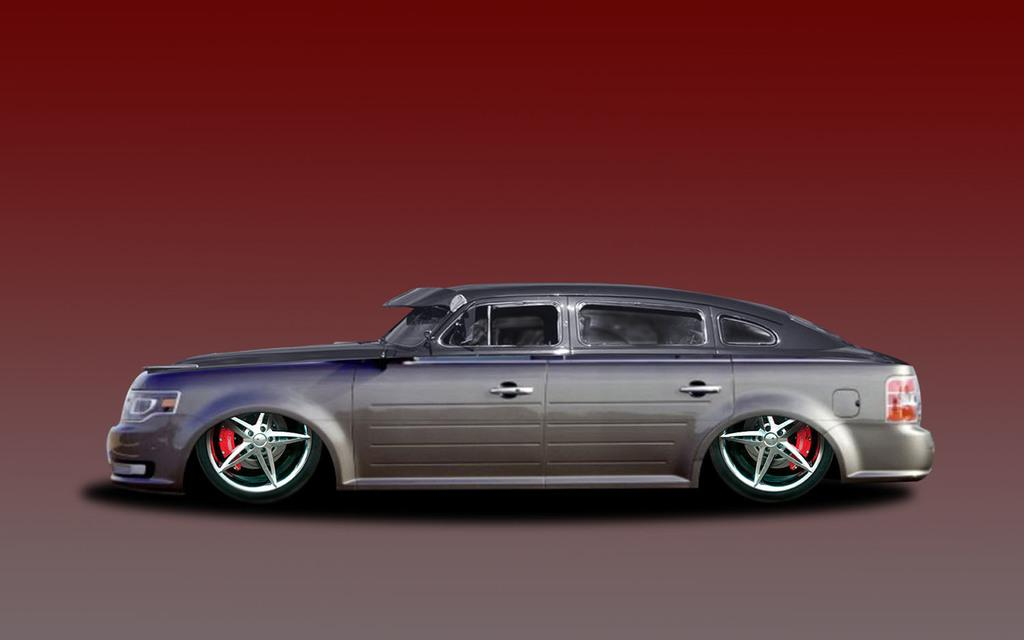What is the main subject of the image? There is a car in the image. Can you describe the background of the image? There is a brown color in the background of the image. What type of dinner is being served in the image? There is no dinner present in the image; it features a car and a brown background. What type of building can be seen in the image? There is no building present in the image; it features a car and a brown background. 